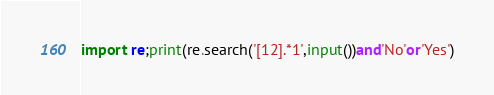<code> <loc_0><loc_0><loc_500><loc_500><_Python_>import re;print(re.search('[12].*1',input())and'No'or'Yes')</code> 